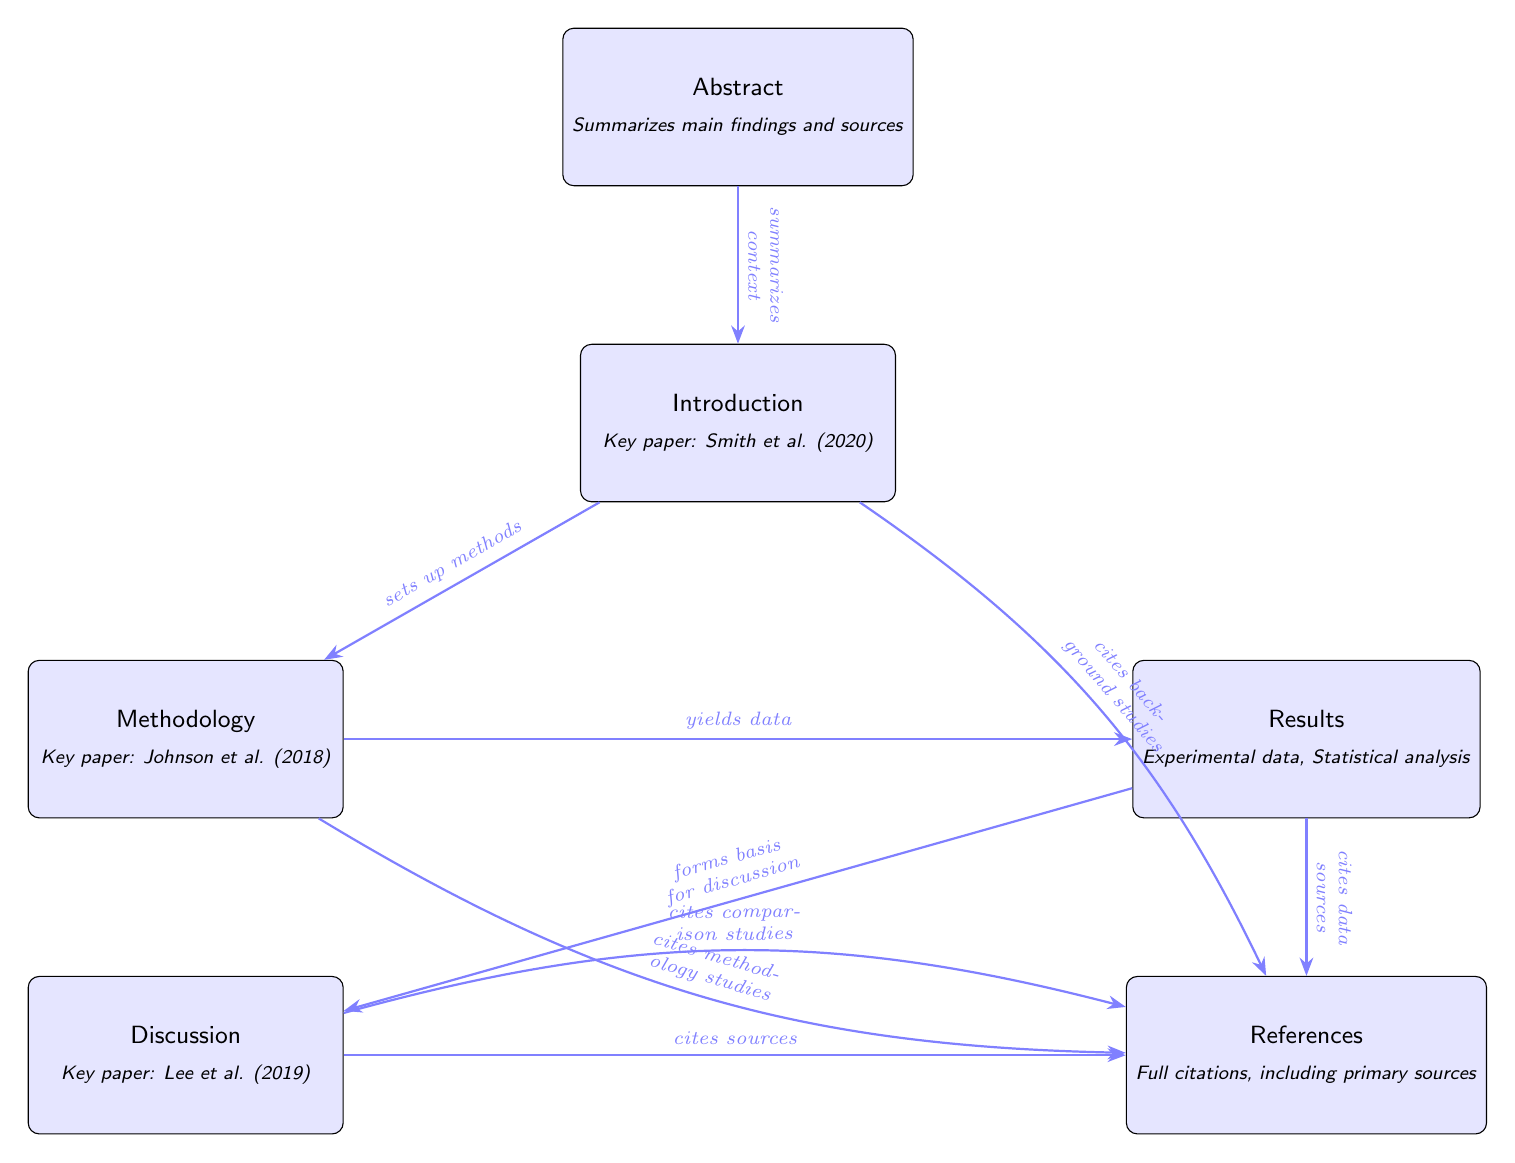What are the five main sections of the research paper? The diagram includes five main sections: Abstract, Introduction, Methodology, Results, and Discussion.
Answer: Abstract, Introduction, Methodology, Results, Discussion Which section provides a summary of main findings? The diagram shows that the Abstract section summarizes the main findings of the research.
Answer: Abstract What is the role of the Introduction in the diagram? The Introduction sets up the methods of the research according to the arrows in the diagram that direct from Introduction to Methodology.
Answer: Sets up methods Which key paper is referenced in the Methodology section? The diagram explicitly states that Johnson et al. (2018) is the key paper referenced in the Methodology section.
Answer: Johnson et al. (2018) How many edges are there connecting the Abstract to other sections? The diagram shows that the Abstract has one directed edge connecting to the Introduction section.
Answer: 1 Describe the flow from Results to Discussion in the diagram. The edge from Results to Discussion indicates that the Results form the basis for the Discussion, highlighting that the findings are analyzed in that section.
Answer: Forms basis for discussion Which section cites comparison studies? The diagram indicates that the Discussion section cites comparison studies based on the descriptive edge leading from Discussion to References.
Answer: Discussion What is learned from the Results section about data sources? The diagram indicates that the Results section cites data sources, providing information about where the data was obtained.
Answer: Cites data sources Which section includes full citations? According to the diagram, the References section includes full citations, which consist of all related sources.
Answer: References 